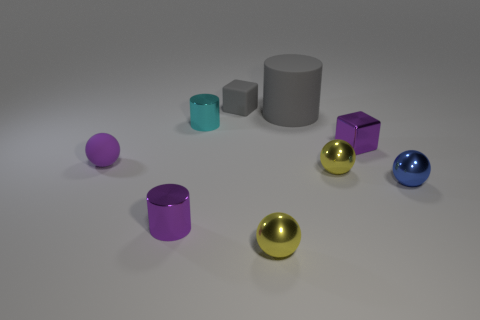What color is the other shiny cylinder that is the same size as the cyan metallic cylinder? The other cylinder that matches the size of the cyan metallic cylinder is a rich purple hue with a glossy finish, evoking a feeling of luxury and depth. 